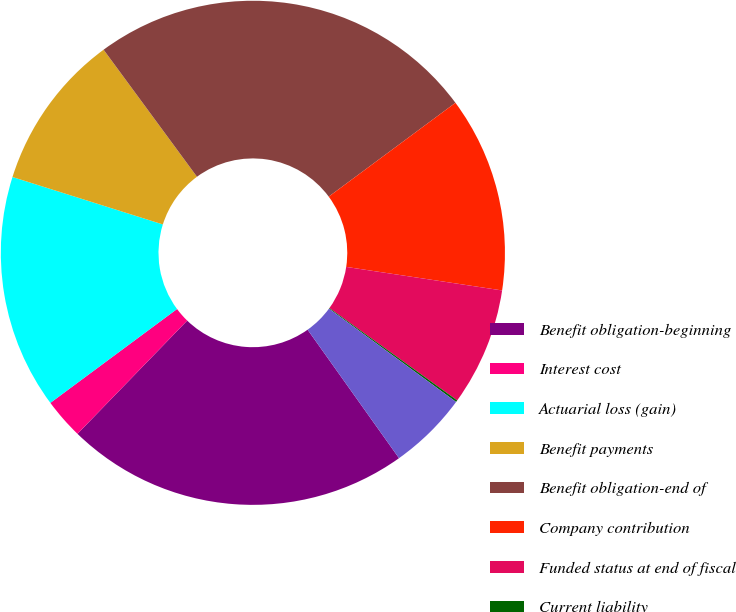Convert chart. <chart><loc_0><loc_0><loc_500><loc_500><pie_chart><fcel>Benefit obligation-beginning<fcel>Interest cost<fcel>Actuarial loss (gain)<fcel>Benefit payments<fcel>Benefit obligation-end of<fcel>Company contribution<fcel>Funded status at end of fiscal<fcel>Current liability<fcel>Non-current liability<nl><fcel>22.09%<fcel>2.6%<fcel>15.01%<fcel>10.05%<fcel>24.94%<fcel>12.53%<fcel>7.57%<fcel>0.12%<fcel>5.08%<nl></chart> 